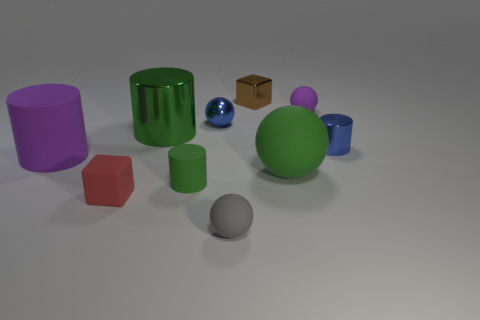There is a small gray thing right of the green object that is behind the large matte cylinder; is there a tiny rubber cylinder that is in front of it?
Offer a terse response. No. How many objects are either small metallic objects that are on the right side of the gray rubber sphere or rubber spheres behind the gray thing?
Your answer should be compact. 4. Is the tiny sphere that is in front of the purple rubber cylinder made of the same material as the tiny green cylinder?
Make the answer very short. Yes. There is a object that is both behind the tiny blue sphere and in front of the metallic block; what material is it?
Your response must be concise. Rubber. There is a small cylinder to the right of the blue shiny thing left of the small brown block; what color is it?
Give a very brief answer. Blue. There is a small green object that is the same shape as the big purple thing; what is its material?
Offer a terse response. Rubber. There is a tiny thing to the right of the purple rubber object that is to the right of the tiny cube that is left of the big metallic cylinder; what color is it?
Make the answer very short. Blue. What number of things are either green matte objects or large spheres?
Give a very brief answer. 2. What number of tiny purple rubber things have the same shape as the big purple thing?
Ensure brevity in your answer.  0. Do the small green object and the big green object that is behind the big purple object have the same material?
Make the answer very short. No. 